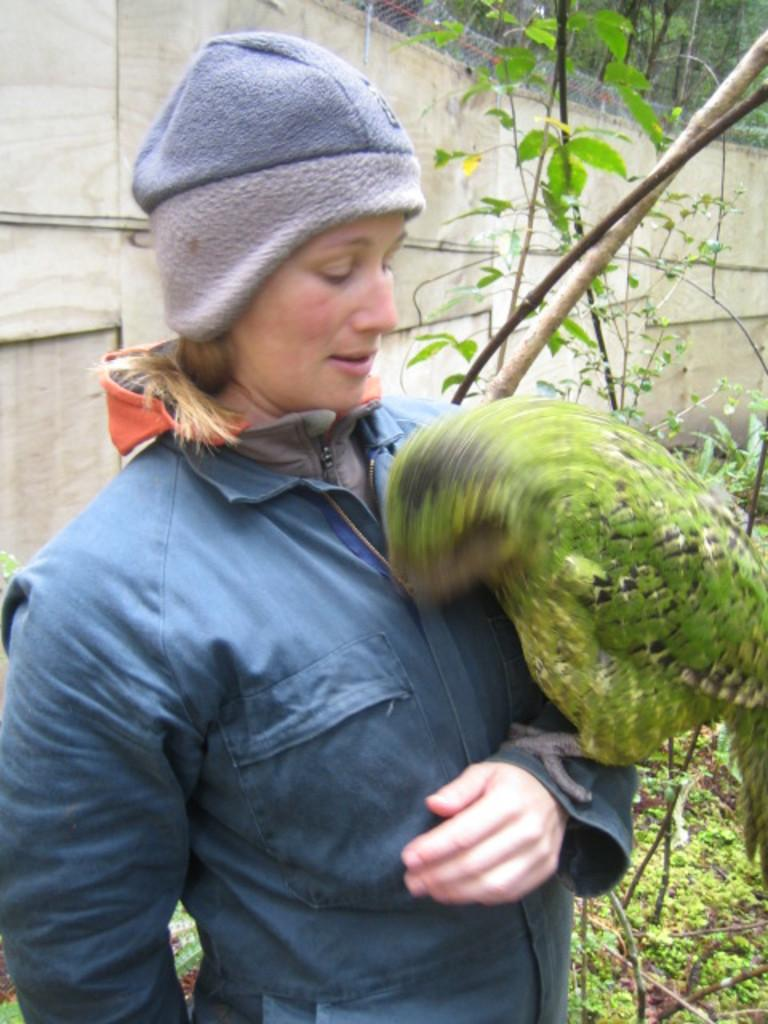Who or what is present in the image? There is a person and a bird in the image. What can be seen in the background of the image? There is a wall and trees in the background of the image. What type of beetle can be seen crawling on the person's shoulder in the image? There is no beetle present on the person's shoulder in the image. 